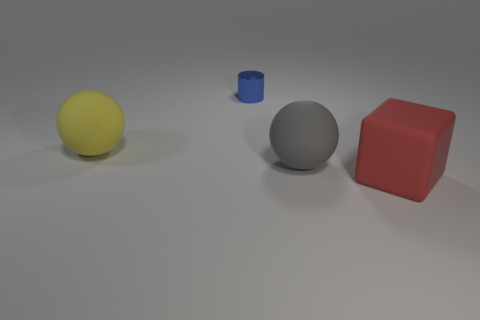Add 3 tiny green rubber balls. How many objects exist? 7 Subtract all cylinders. How many objects are left? 3 Subtract 1 blocks. How many blocks are left? 0 Subtract all green spheres. How many green cubes are left? 0 Subtract all large brown metallic blocks. Subtract all big spheres. How many objects are left? 2 Add 3 small blue objects. How many small blue objects are left? 4 Add 1 purple shiny things. How many purple shiny things exist? 1 Subtract 0 green cubes. How many objects are left? 4 Subtract all blue balls. Subtract all cyan cubes. How many balls are left? 2 